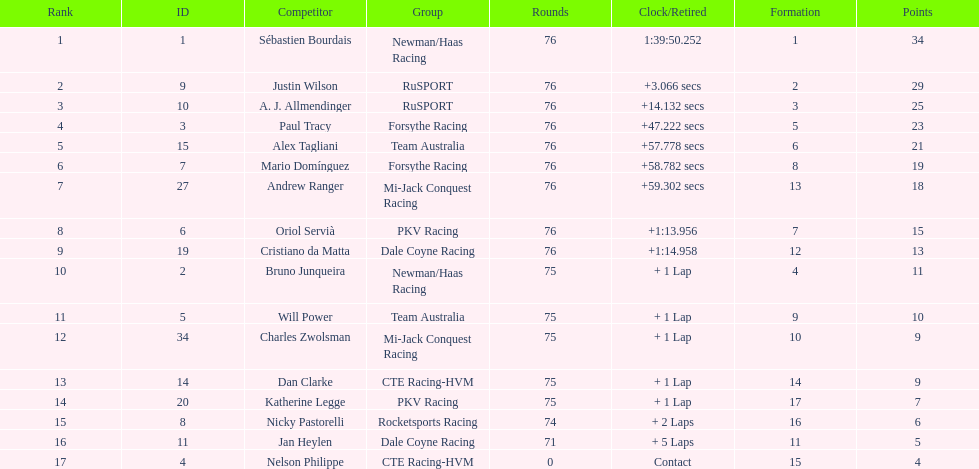Charles zwolsman acquired the same number of points as who? Dan Clarke. 